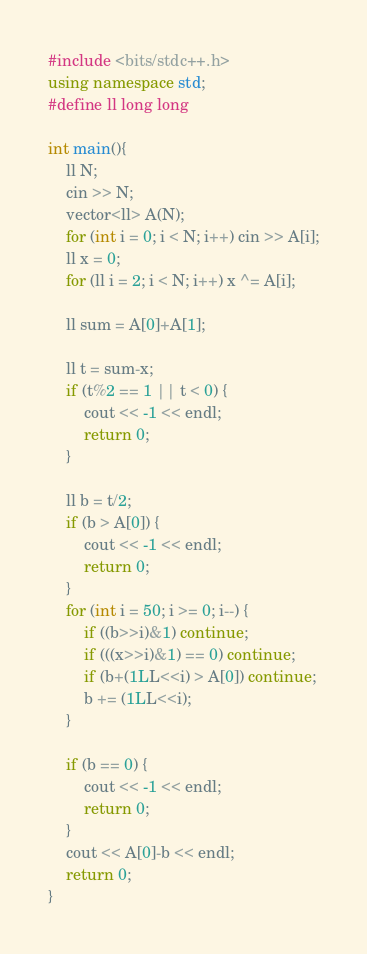<code> <loc_0><loc_0><loc_500><loc_500><_C++_>#include <bits/stdc++.h>
using namespace std;
#define ll long long

int main(){
    ll N;
    cin >> N;
    vector<ll> A(N);
    for (int i = 0; i < N; i++) cin >> A[i];
    ll x = 0;
    for (ll i = 2; i < N; i++) x ^= A[i];
    
    ll sum = A[0]+A[1];
    
    ll t = sum-x;
    if (t%2 == 1 || t < 0) {
        cout << -1 << endl;
        return 0;
    }
    
    ll b = t/2;
    if (b > A[0]) {
        cout << -1 << endl;
        return 0;
    }
    for (int i = 50; i >= 0; i--) {
        if ((b>>i)&1) continue;
        if (((x>>i)&1) == 0) continue;
        if (b+(1LL<<i) > A[0]) continue;
        b += (1LL<<i);
    }
    
    if (b == 0) {
        cout << -1 << endl;
        return 0;
    }
    cout << A[0]-b << endl;
    return 0;
}
</code> 